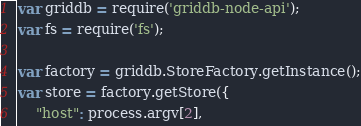Convert code to text. <code><loc_0><loc_0><loc_500><loc_500><_JavaScript_>var griddb = require('griddb-node-api');
var fs = require('fs');

var factory = griddb.StoreFactory.getInstance();
var store = factory.getStore({
    "host": process.argv[2],</code> 